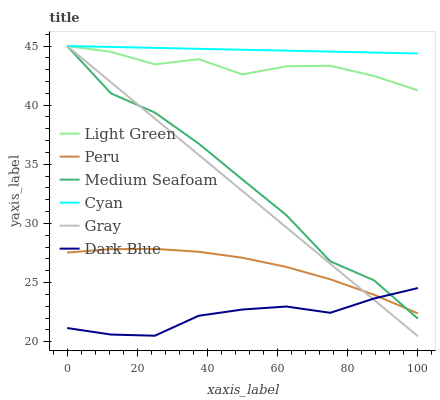Does Dark Blue have the minimum area under the curve?
Answer yes or no. Yes. Does Cyan have the maximum area under the curve?
Answer yes or no. Yes. Does Light Green have the minimum area under the curve?
Answer yes or no. No. Does Light Green have the maximum area under the curve?
Answer yes or no. No. Is Cyan the smoothest?
Answer yes or no. Yes. Is Medium Seafoam the roughest?
Answer yes or no. Yes. Is Light Green the smoothest?
Answer yes or no. No. Is Light Green the roughest?
Answer yes or no. No. Does Gray have the lowest value?
Answer yes or no. Yes. Does Light Green have the lowest value?
Answer yes or no. No. Does Medium Seafoam have the highest value?
Answer yes or no. Yes. Does Dark Blue have the highest value?
Answer yes or no. No. Is Dark Blue less than Light Green?
Answer yes or no. Yes. Is Light Green greater than Peru?
Answer yes or no. Yes. Does Gray intersect Cyan?
Answer yes or no. Yes. Is Gray less than Cyan?
Answer yes or no. No. Is Gray greater than Cyan?
Answer yes or no. No. Does Dark Blue intersect Light Green?
Answer yes or no. No. 